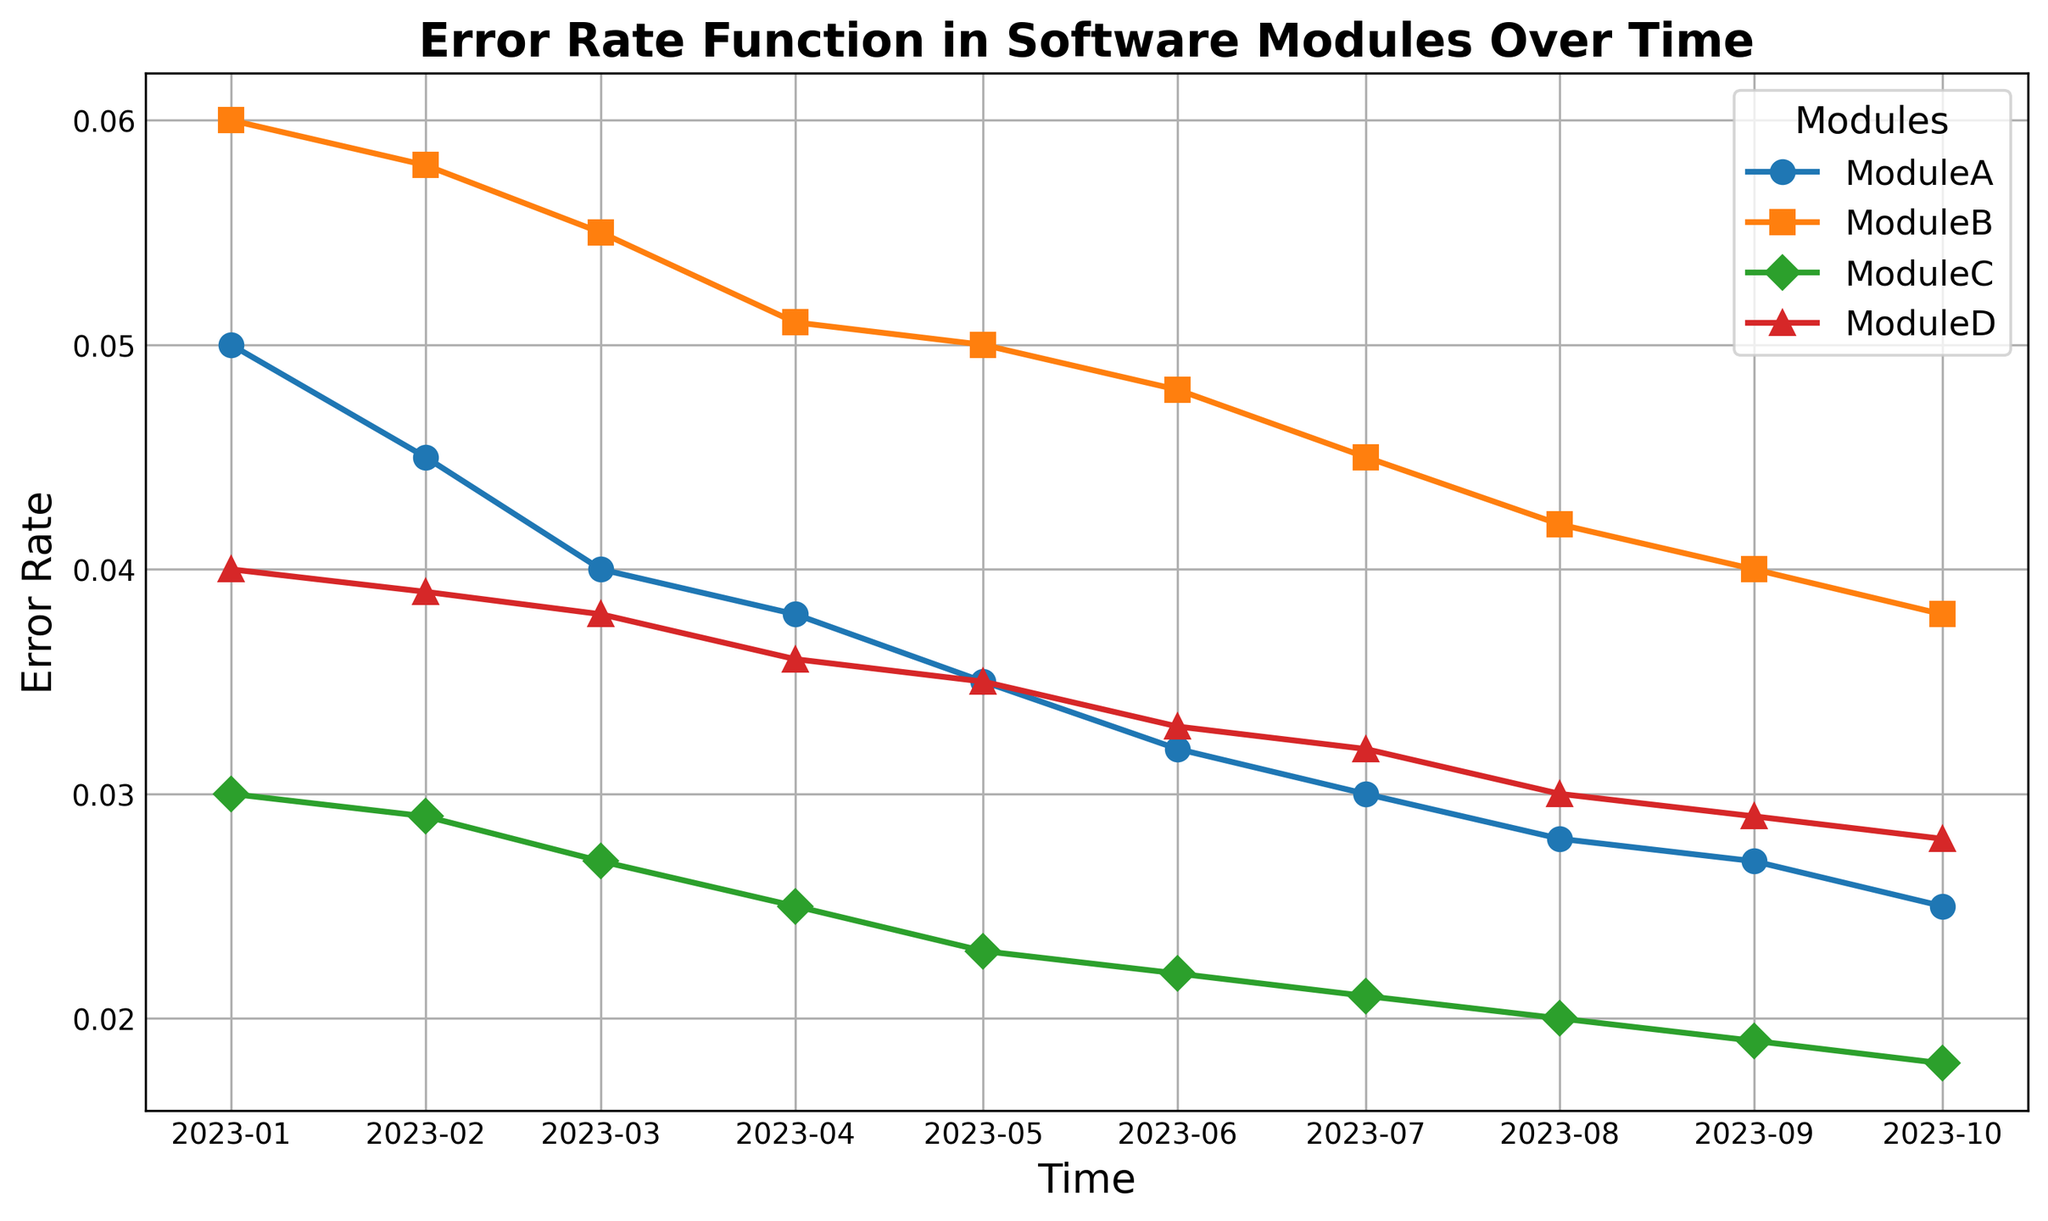Which module starts with the highest error rate in January 2023? By looking at the starting points of each module in January 2023, we can see that Module B has the highest error rate of 0.06.
Answer: Module B What is the average error rate of Module A over the entire period? The error rates for Module A from January to October 2023 are 0.05, 0.045, 0.04, 0.038, 0.035, 0.032, 0.03, 0.028, 0.027, 0.025. Summing these gives 0.35 and dividing by 10 gives the average error rate of 0.035.
Answer: 0.035 Between which months does Module D's error rate show the largest decrease? To find the largest decrease, we note the error rates which decrease steadily. The largest decrease occurs between January and February, where it drops from 0.04 to 0.039.
Answer: January to February Which module has the lowest error rate by October 2023? Referring to the ending points of each module in October 2023, Module C has the lowest error rate of 0.018.
Answer: Module C Which module shows the most consistent decline in error rate over the months? By visually observing the slopes of the error rates, Module C shows a consistent and smooth decline over the specified months without drastic drops or rises.
Answer: Module C How much did the error rate of Module B decrease from January to October 2023? The error rate for Module B in January 2023 is 0.06 and in October 2023 is 0.038. The decrease is calculated as 0.06 - 0.038, which equals 0.022.
Answer: 0.022 What is the total reduction in error rate for Module A from February to September 2023? Error rates from February to September for Module A are 0.045, 0.04, 0.038, 0.035, 0.032, 0.03, 0.028, 0.027 respectively. Calculating the initial rate (0.045) minus the final rate (0.027) gives a total reduction of 0.018.
Answer: 0.018 Which month's error rate shows the smallest change for Module D? Looking at the changes month-by-month for Module D, from August to September 2023 the error rate drops from 0.03 to 0.029, the smallest change of 0.001.
Answer: August to September 